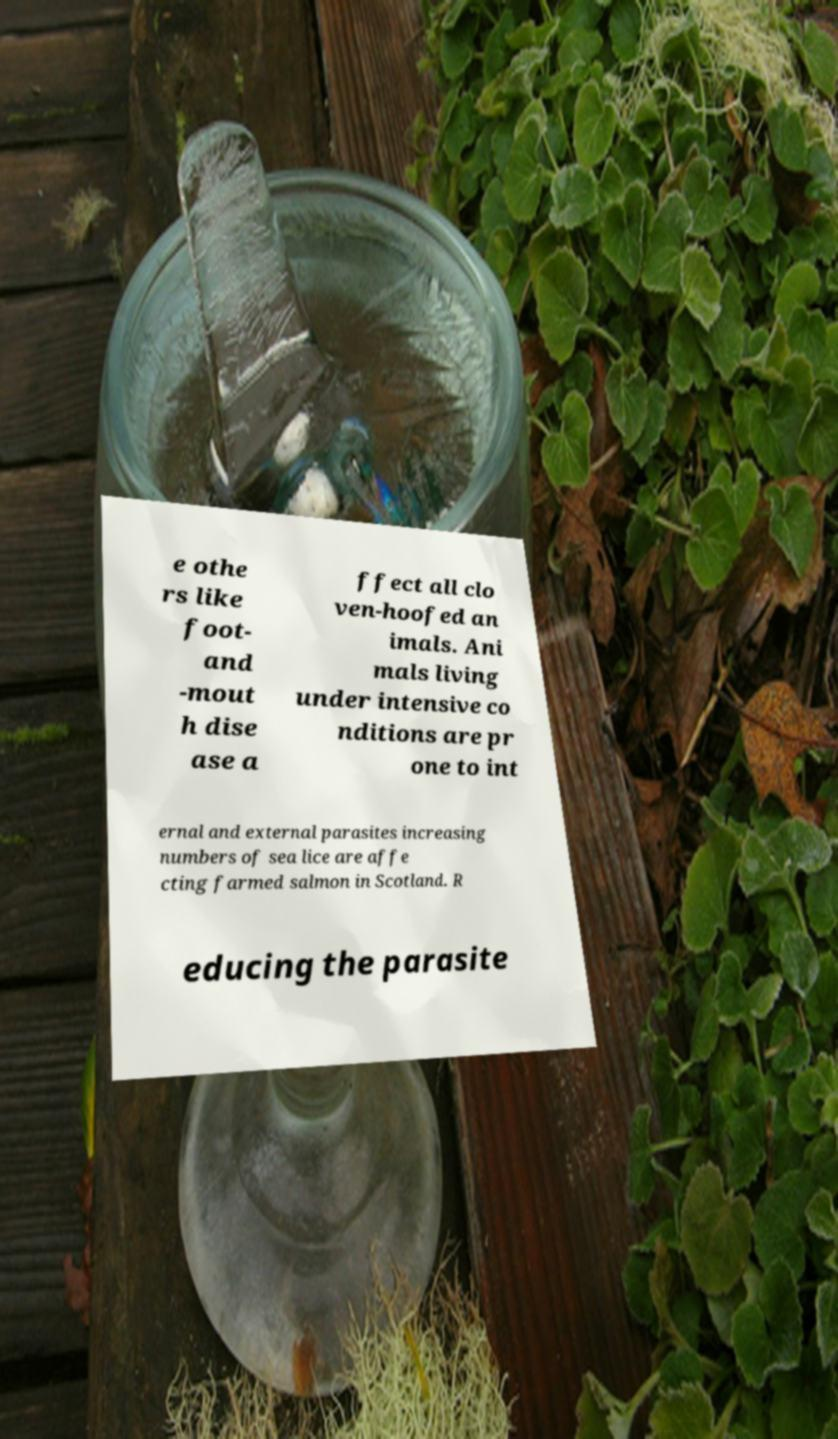Could you assist in decoding the text presented in this image and type it out clearly? e othe rs like foot- and -mout h dise ase a ffect all clo ven-hoofed an imals. Ani mals living under intensive co nditions are pr one to int ernal and external parasites increasing numbers of sea lice are affe cting farmed salmon in Scotland. R educing the parasite 